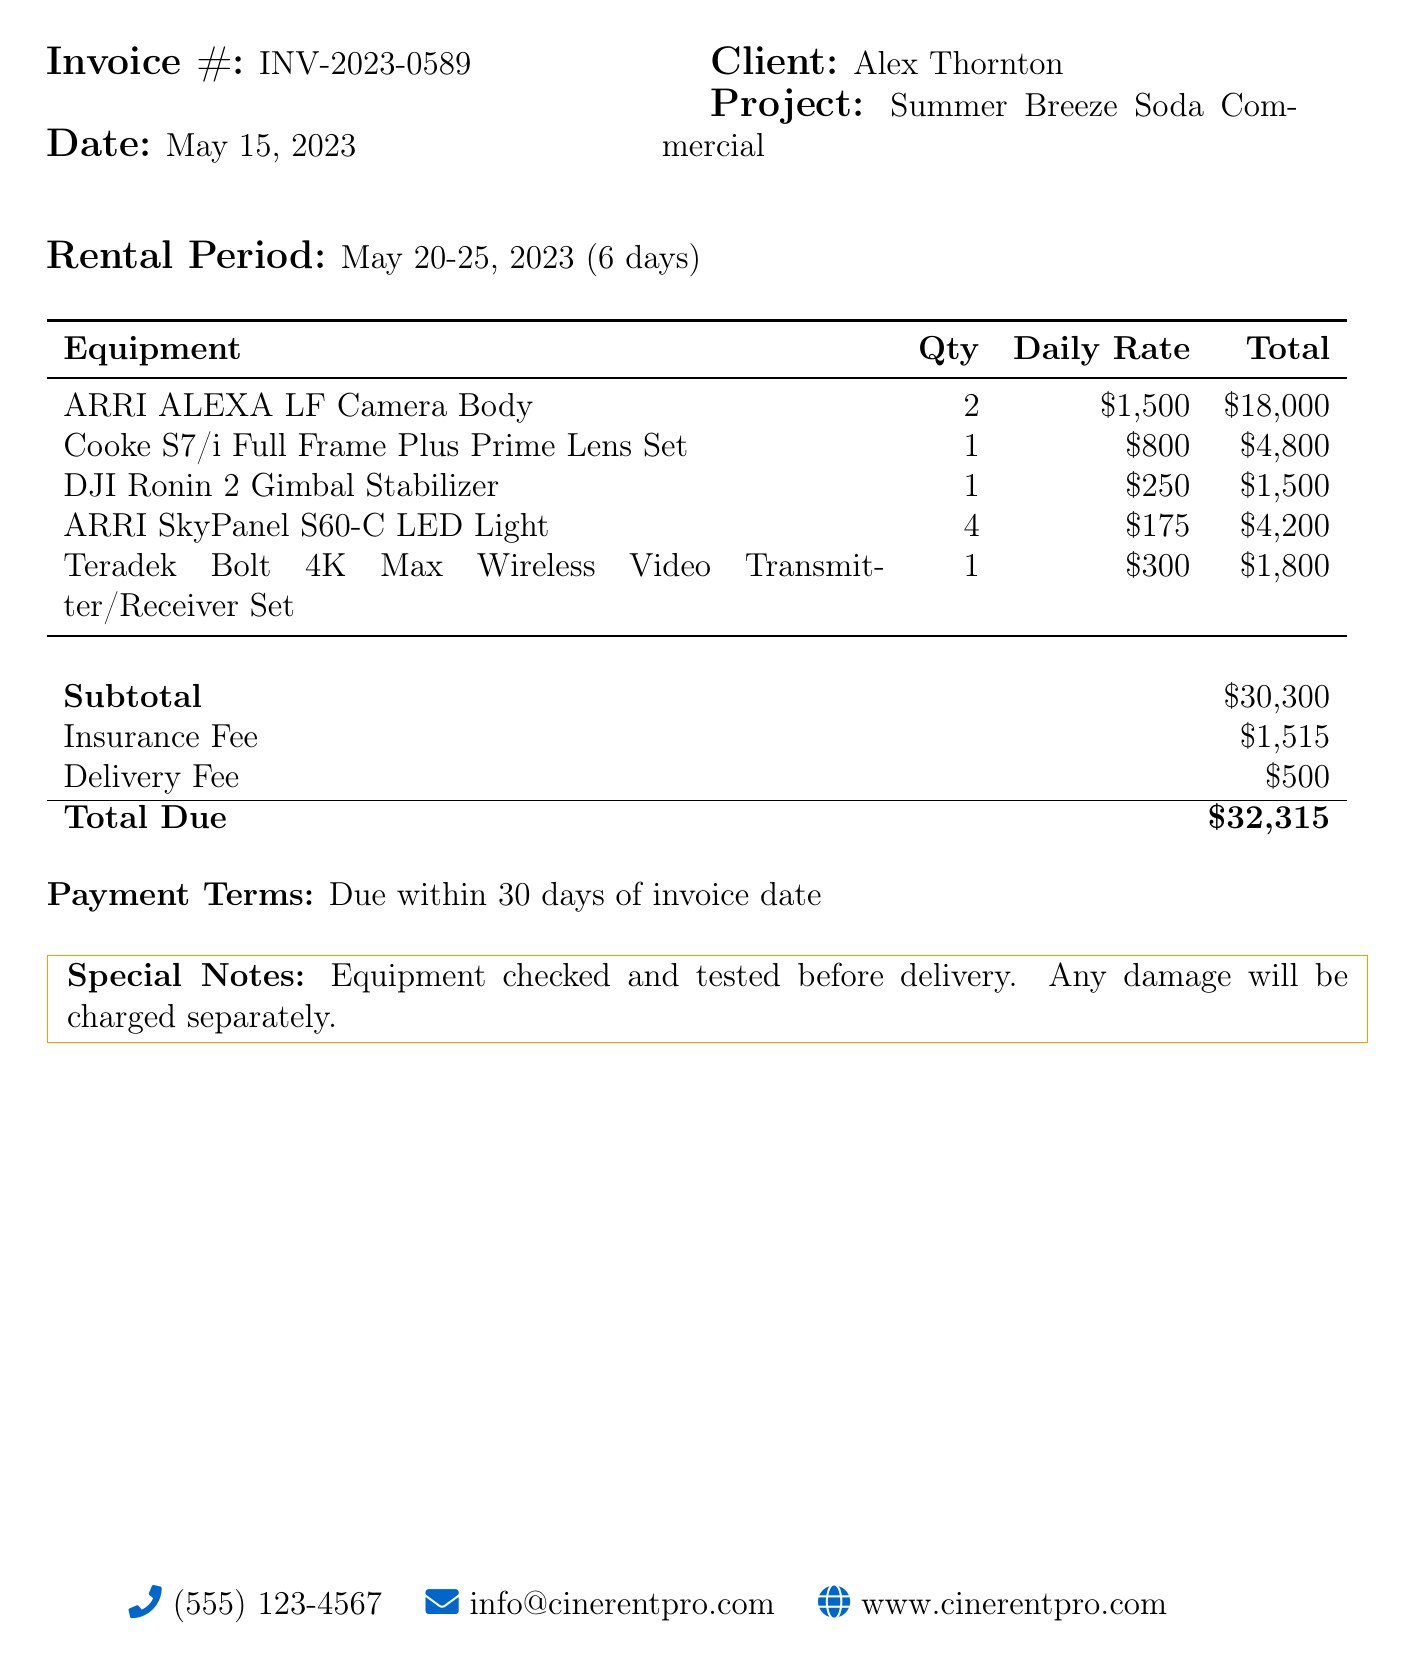what is the invoice number? The invoice number is clearly indicated in the document as INV-2023-0589.
Answer: INV-2023-0589 what is the client name? The client's name is specified in the document as Alex Thornton.
Answer: Alex Thornton what is the rental period? The document states the rental period as May 20-25, 2023 (6 days).
Answer: May 20-25, 2023 (6 days) what is the total due amount? The total due amount is detailed at the end of the document as $32,315.
Answer: $32,315 how many ARRI ALEXA LF Camera Bodies were rented? The quantity for ARRI ALEXA LF Camera Bodies is listed as 2 in the equipment list.
Answer: 2 what is the subtotal before fees? The subtotal before fees is noted as $30,300 in the document.
Answer: $30,300 what is the insurance fee? The insurance fee is mentioned as $1,515.
Answer: $1,515 what is the delivery fee? The document specifies the delivery fee as $500.
Answer: $500 what are the payment terms? The payment terms are indicated as due within 30 days of invoice date.
Answer: Due within 30 days of invoice date 